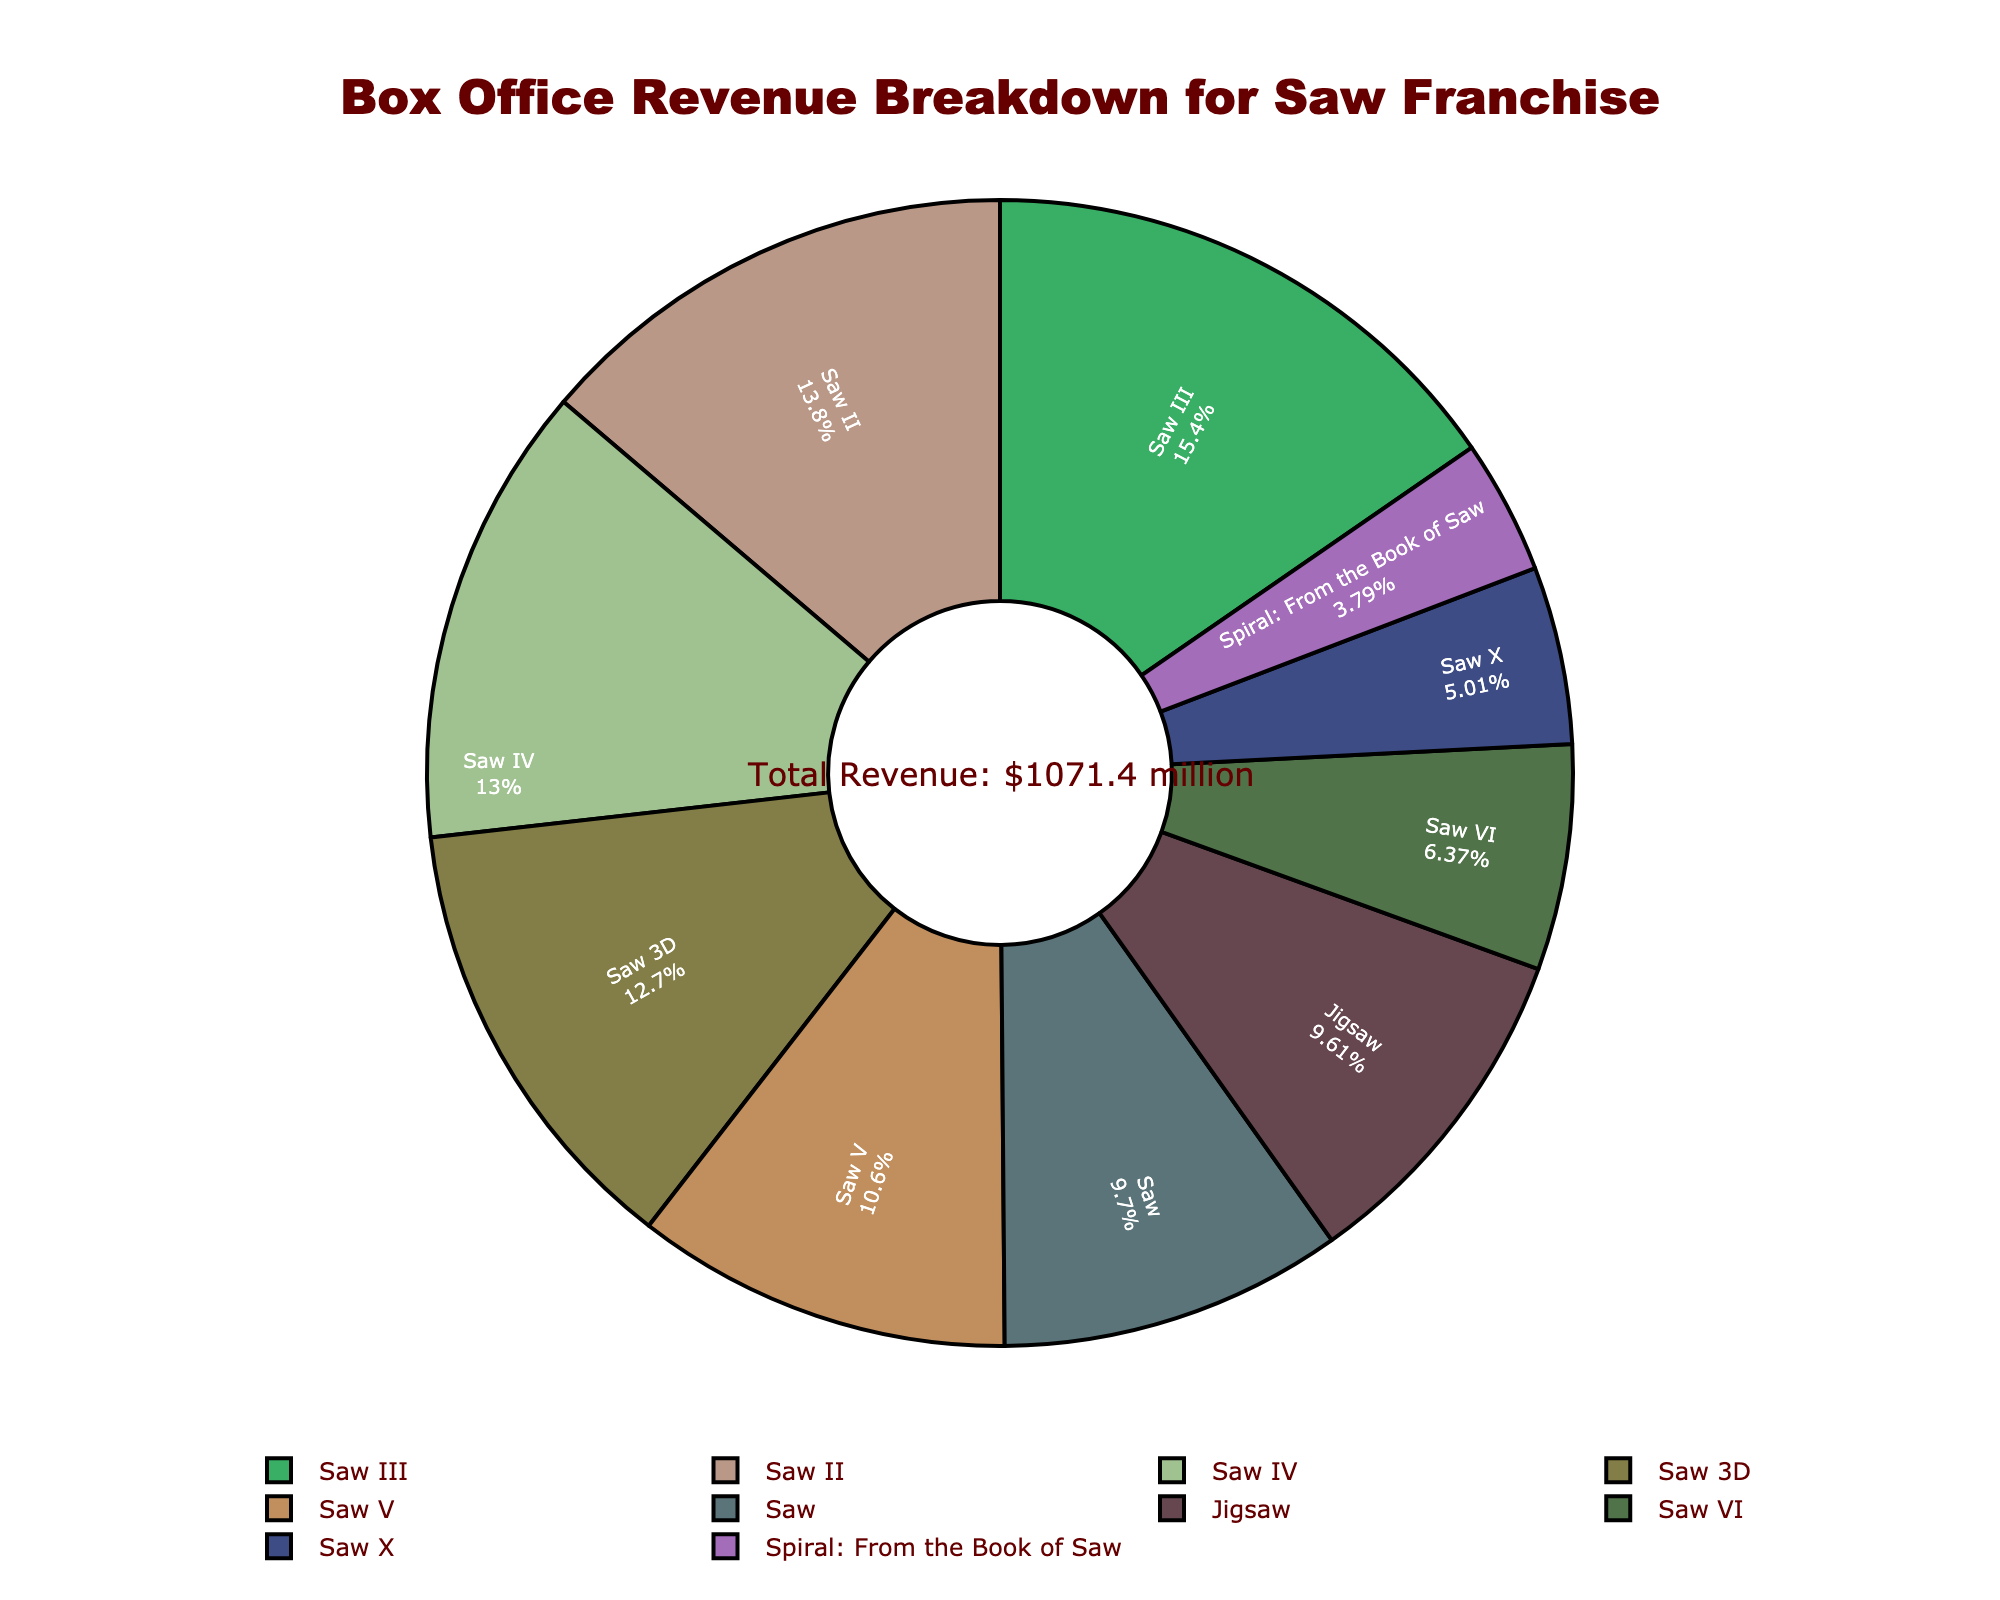Which Saw movie has the highest box office revenue? By looking at the pie chart, the segment with the highest revenue corresponds to "Saw III".
Answer: Saw III Which Saw movie has the lowest box office revenue? The smallest segment in the pie chart represents "Spiral: From the Book of Saw".
Answer: Spiral: From the Book of Saw What's the total revenue of the Saw franchise? There's an annotation in the center of the pie chart that mentions the total revenue, which sums up all the individual revenues.
Answer: $1,071.4 million How do the revenues of Saw IV and Saw 3D compare? By visually comparing the segments in the pie chart, the revenues of Saw IV and Saw 3D look very similar.
Answer: Approximately equal What's the combined revenue of Saw, Saw II, and Saw III? Add the individual revenues: Saw ($103.9 million) + Saw II ($147.7 million) + Saw III ($164.9 million).
Answer: $416.5 million Which movie has the closest revenue to "Saw X"? By comparing the pie chart segments, "Saw VI" is closest to "Saw X" in revenue.
Answer: Saw VI What percentage of the total revenue is attributed to "Jigsaw"? Find "Jigsaw" on the pie chart and read the percentage label next to it.
Answer: Approximately 9.6% Comparing Saw V and Saw VI, which one earned more and by how much? Saw VI: $68.2 million; Saw V: $113.9 million; subtract Saw VI from Saw V to find the difference.
Answer: Saw V by $45.7 million What is the average revenue of the movies in the Saw franchise? Sum all revenues ($1,071.4 million), then divide by the number of movies (10).
Answer: $107.1 million 